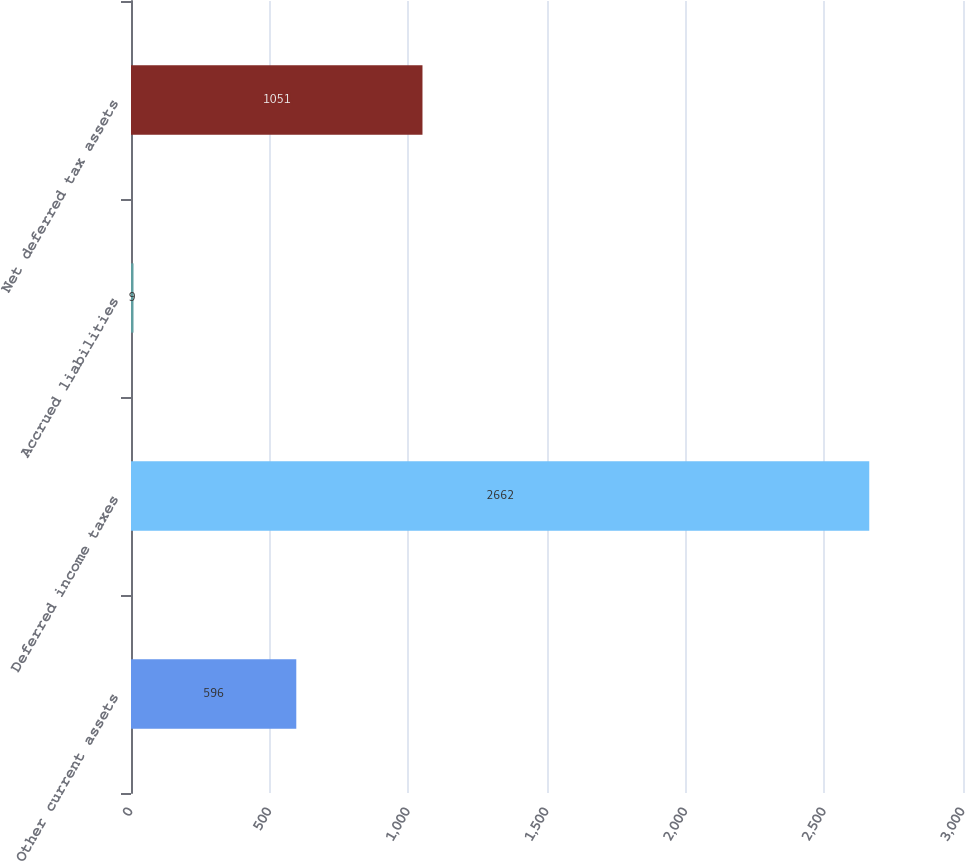Convert chart to OTSL. <chart><loc_0><loc_0><loc_500><loc_500><bar_chart><fcel>Other current assets<fcel>Deferred income taxes<fcel>Accrued liabilities<fcel>Net deferred tax assets<nl><fcel>596<fcel>2662<fcel>9<fcel>1051<nl></chart> 